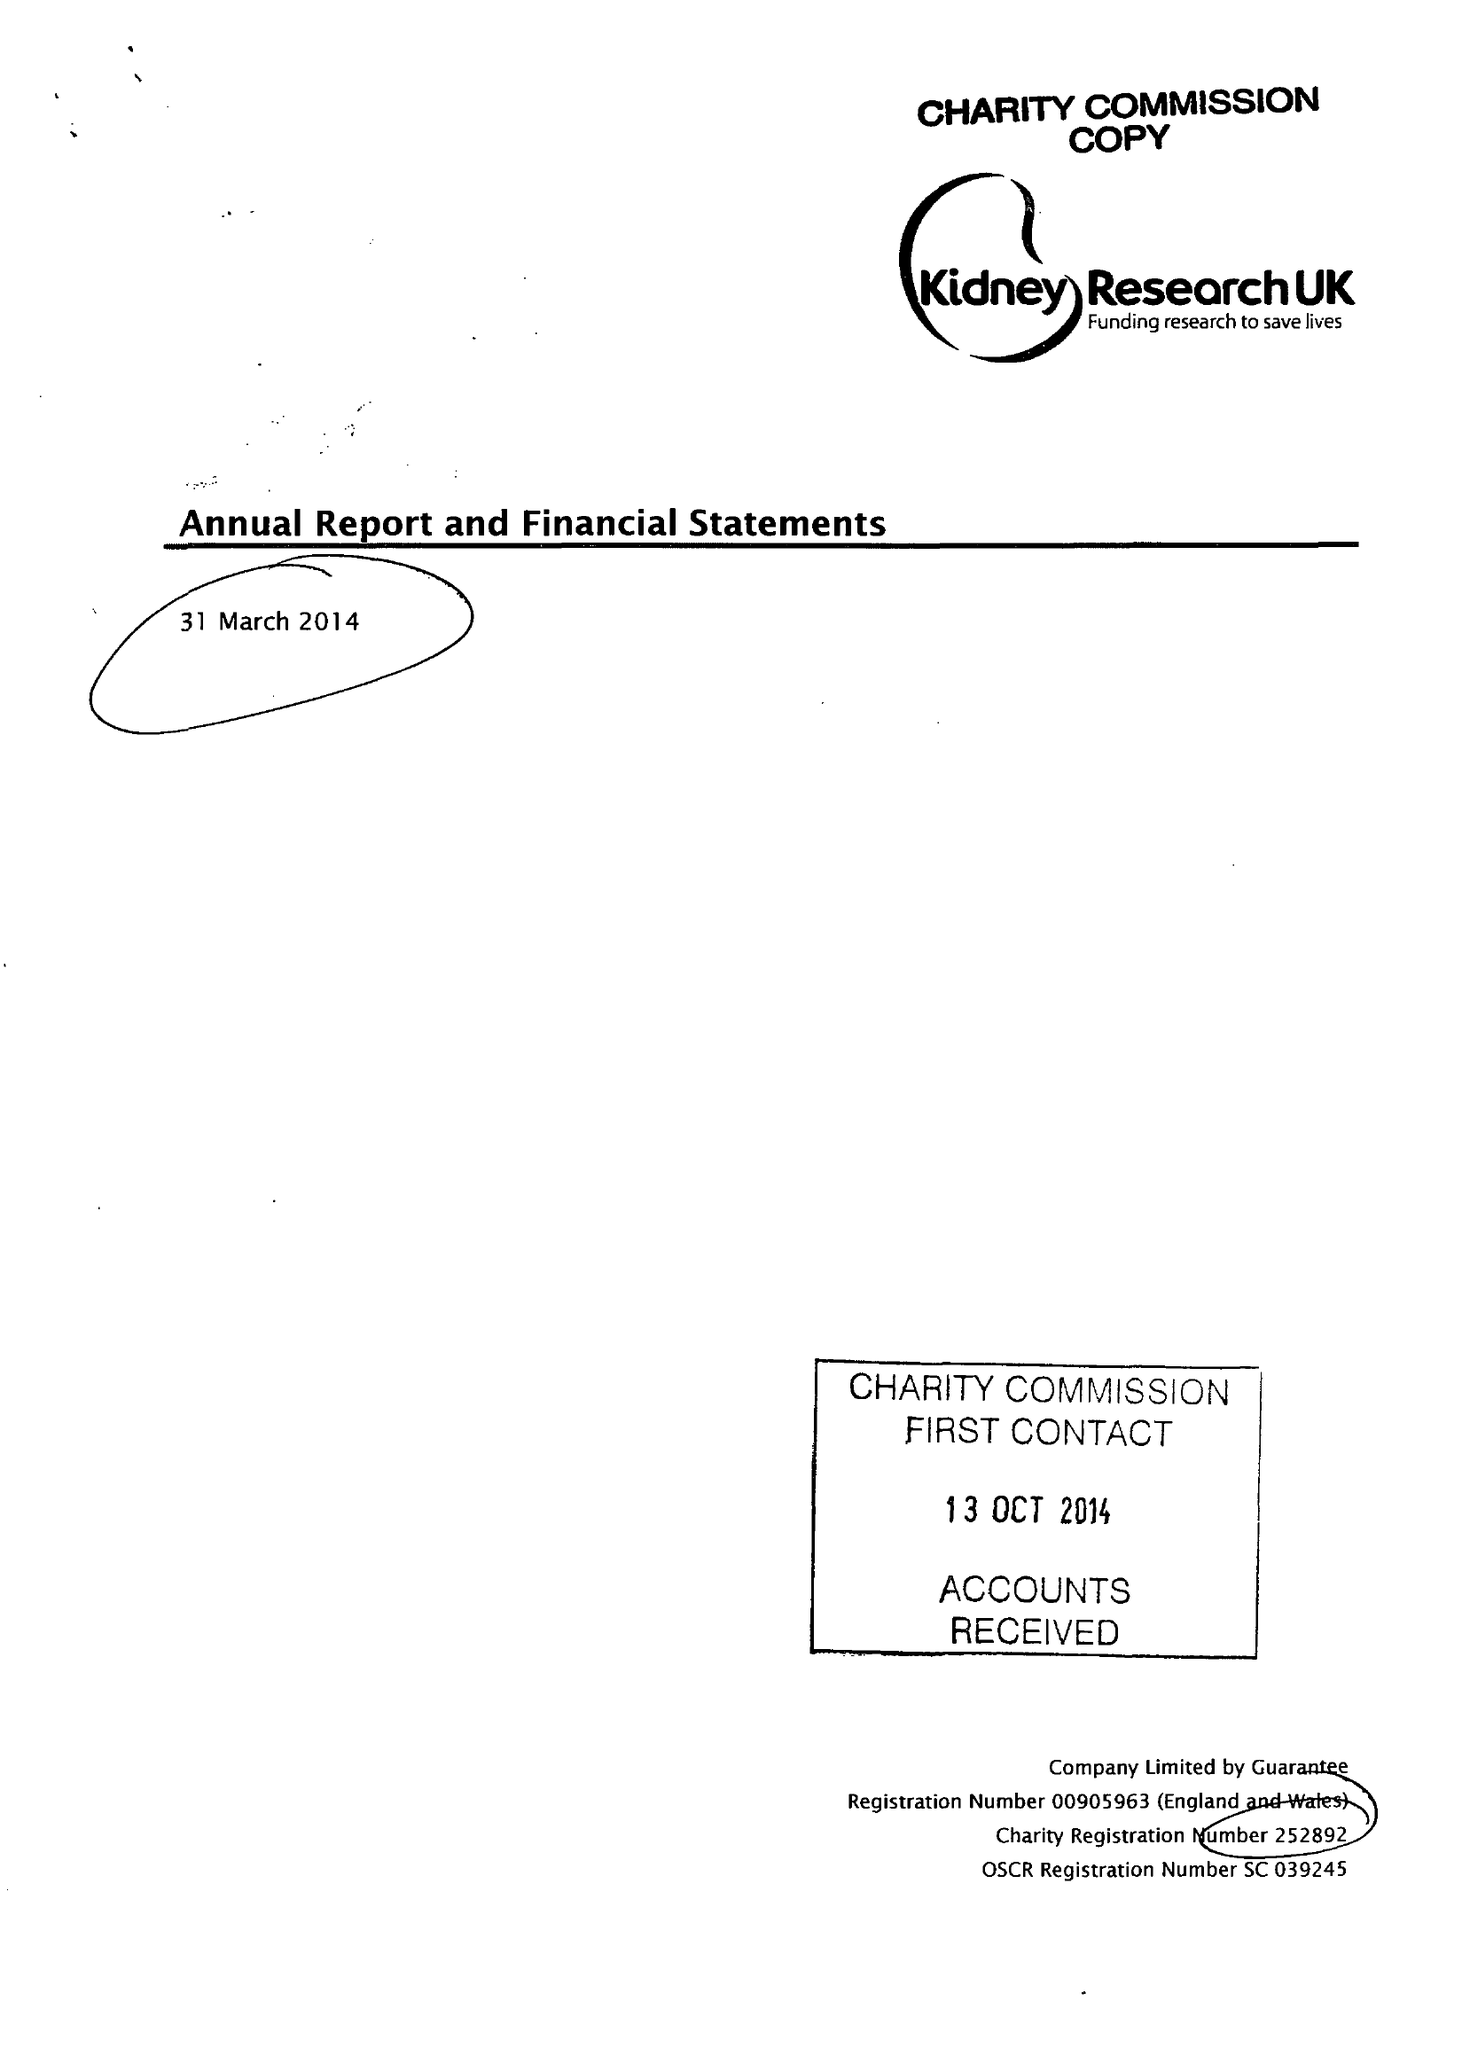What is the value for the spending_annually_in_british_pounds?
Answer the question using a single word or phrase. 8499711.00 